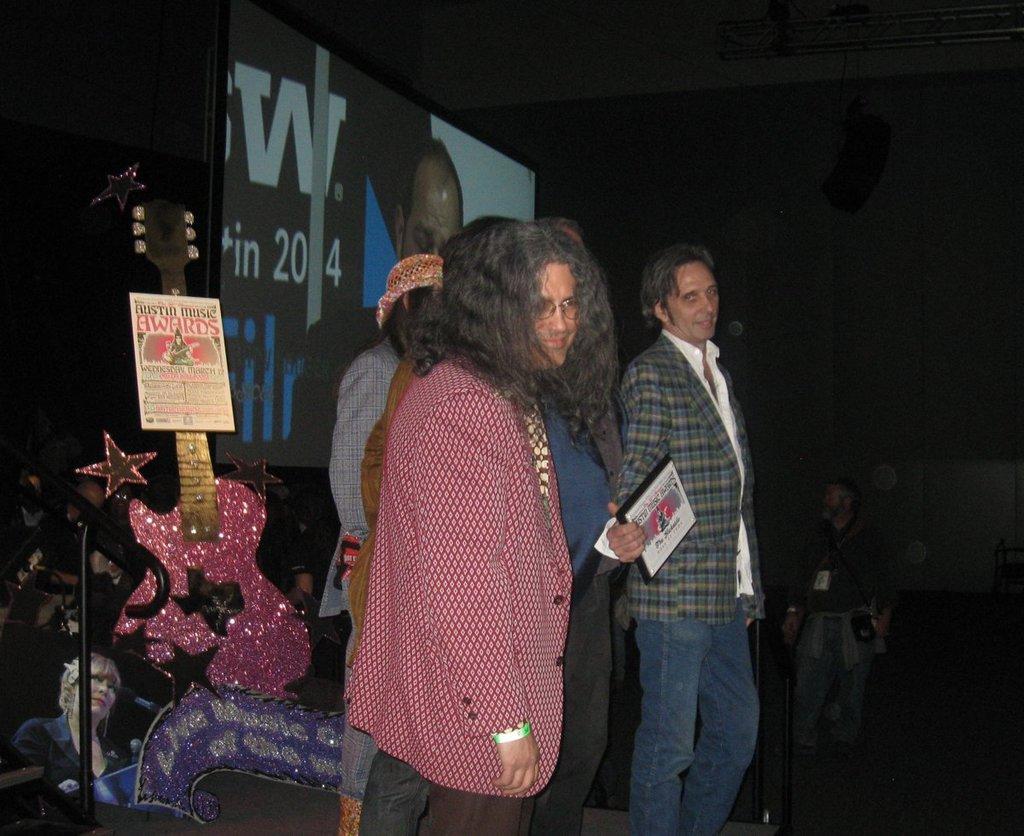Describe this image in one or two sentences. In this picture at the center we can see 4 to 5 people. One of them at the center is holding a memento. In the background there is a screen and also we see a guitar. Here we can see the word awards, it may be presentation ceremony and in the background we can see some crowd. 